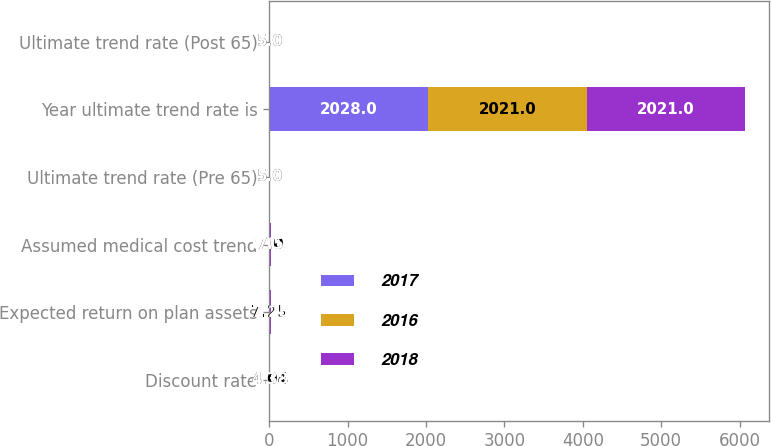<chart> <loc_0><loc_0><loc_500><loc_500><stacked_bar_chart><ecel><fcel>Discount rate<fcel>Expected return on plan assets<fcel>Assumed medical cost trend<fcel>Ultimate trend rate (Pre 65)<fcel>Year ultimate trend rate is<fcel>Ultimate trend rate (Post 65)<nl><fcel>2017<fcel>3.63<fcel>7.25<fcel>6.09<fcel>5<fcel>2028<fcel>5<nl><fcel>2016<fcel>4.04<fcel>7.25<fcel>7<fcel>5<fcel>2021<fcel>5<nl><fcel>2018<fcel>4.38<fcel>7.25<fcel>7.5<fcel>5<fcel>2021<fcel>5<nl></chart> 